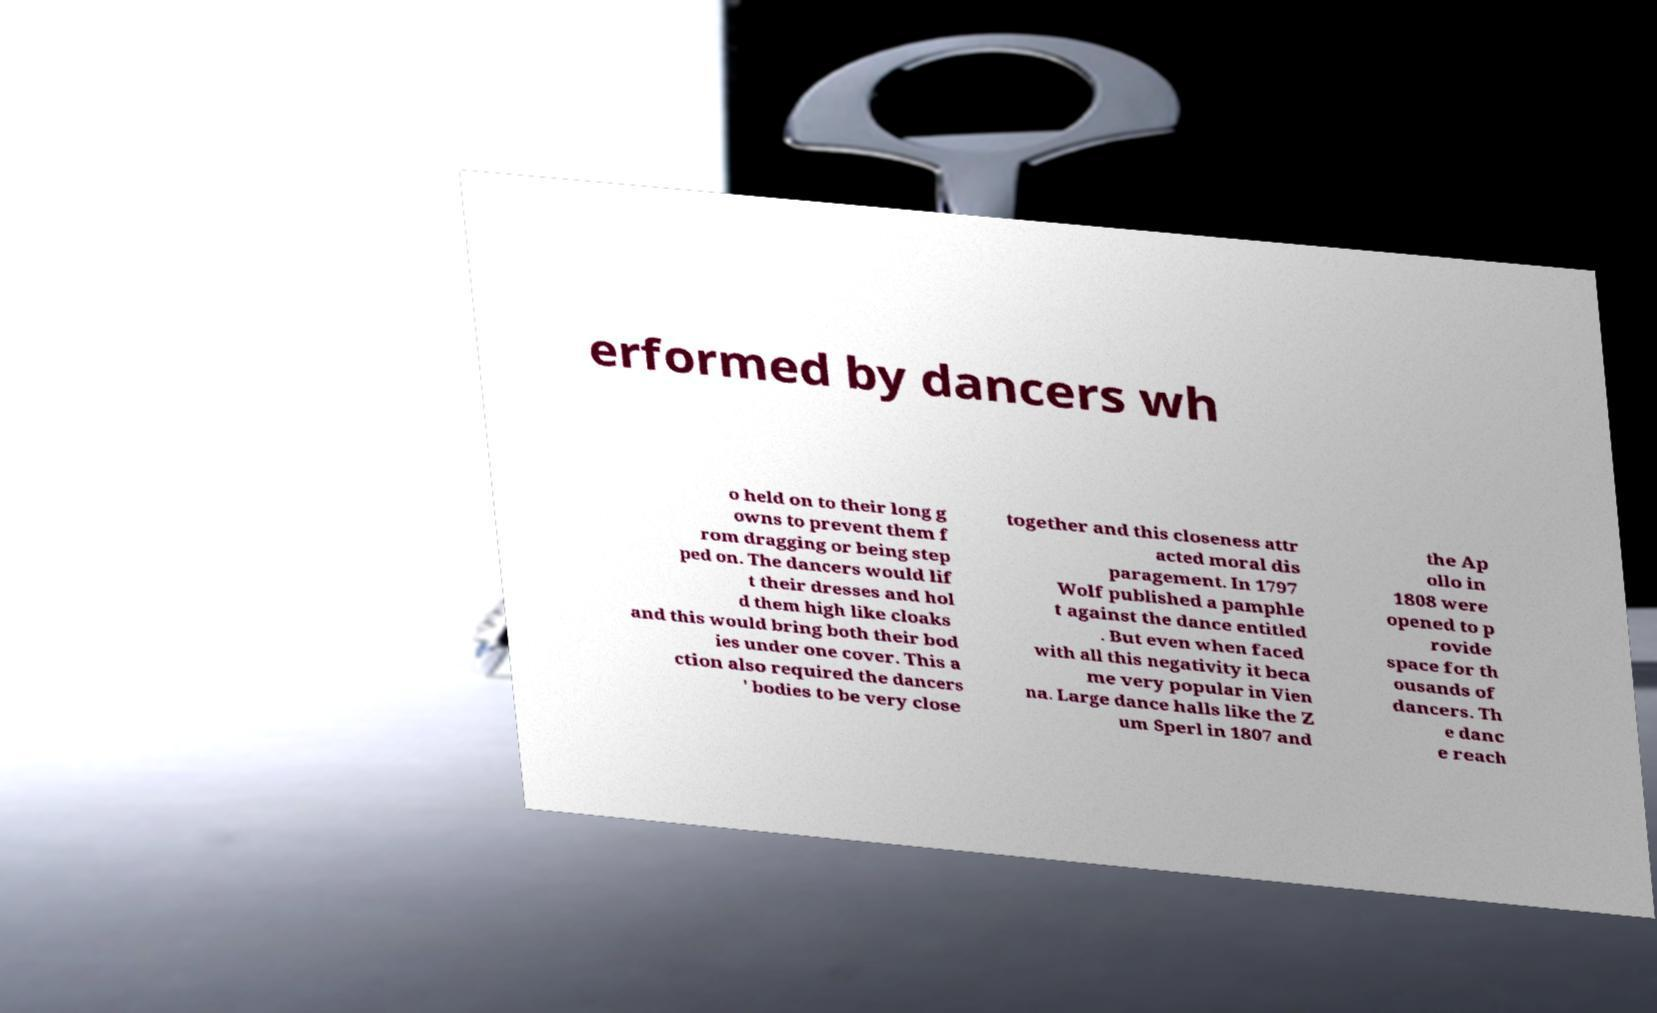I need the written content from this picture converted into text. Can you do that? erformed by dancers wh o held on to their long g owns to prevent them f rom dragging or being step ped on. The dancers would lif t their dresses and hol d them high like cloaks and this would bring both their bod ies under one cover. This a ction also required the dancers ' bodies to be very close together and this closeness attr acted moral dis paragement. In 1797 Wolf published a pamphle t against the dance entitled . But even when faced with all this negativity it beca me very popular in Vien na. Large dance halls like the Z um Sperl in 1807 and the Ap ollo in 1808 were opened to p rovide space for th ousands of dancers. Th e danc e reach 